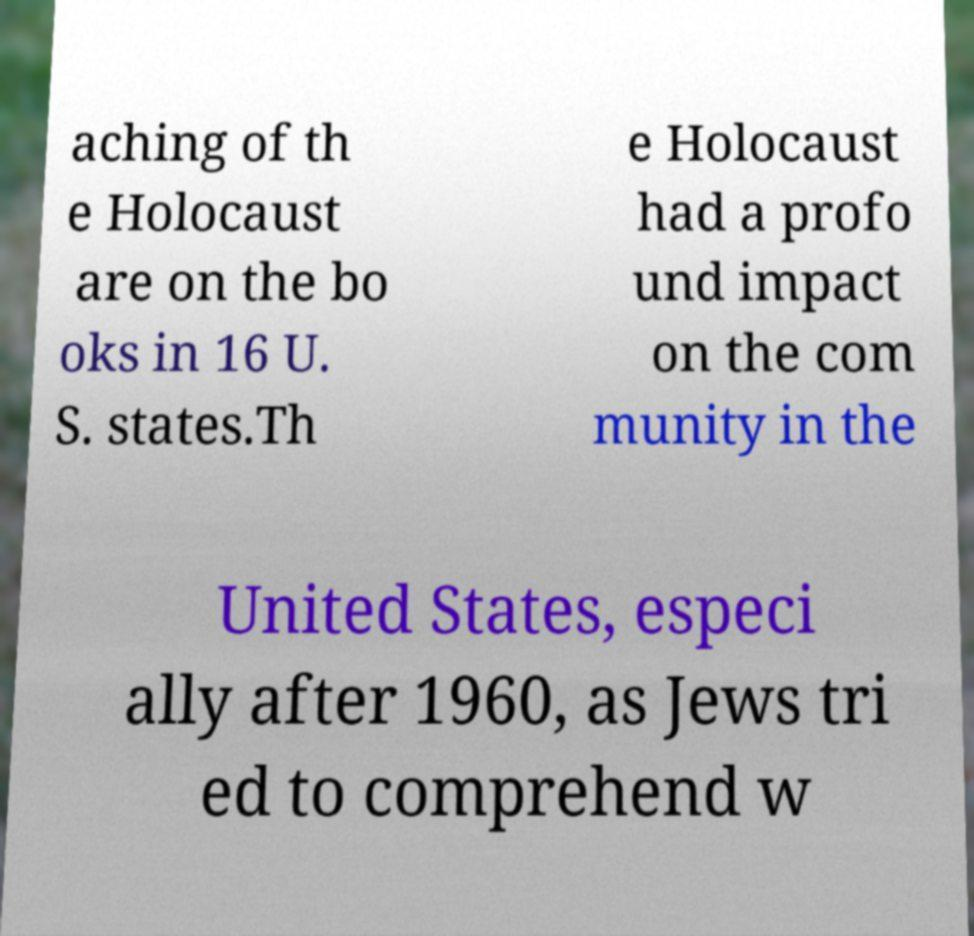Can you accurately transcribe the text from the provided image for me? aching of th e Holocaust are on the bo oks in 16 U. S. states.Th e Holocaust had a profo und impact on the com munity in the United States, especi ally after 1960, as Jews tri ed to comprehend w 